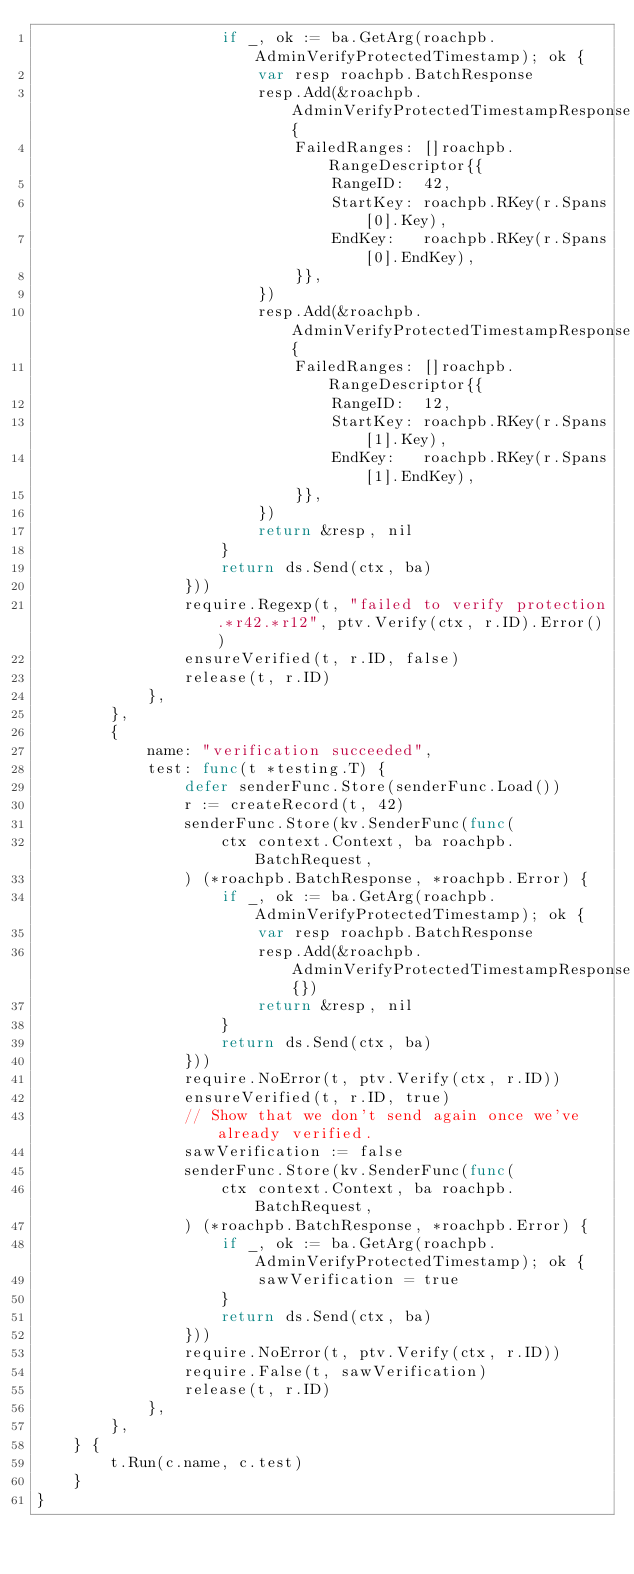<code> <loc_0><loc_0><loc_500><loc_500><_Go_>					if _, ok := ba.GetArg(roachpb.AdminVerifyProtectedTimestamp); ok {
						var resp roachpb.BatchResponse
						resp.Add(&roachpb.AdminVerifyProtectedTimestampResponse{
							FailedRanges: []roachpb.RangeDescriptor{{
								RangeID:  42,
								StartKey: roachpb.RKey(r.Spans[0].Key),
								EndKey:   roachpb.RKey(r.Spans[0].EndKey),
							}},
						})
						resp.Add(&roachpb.AdminVerifyProtectedTimestampResponse{
							FailedRanges: []roachpb.RangeDescriptor{{
								RangeID:  12,
								StartKey: roachpb.RKey(r.Spans[1].Key),
								EndKey:   roachpb.RKey(r.Spans[1].EndKey),
							}},
						})
						return &resp, nil
					}
					return ds.Send(ctx, ba)
				}))
				require.Regexp(t, "failed to verify protection.*r42.*r12", ptv.Verify(ctx, r.ID).Error())
				ensureVerified(t, r.ID, false)
				release(t, r.ID)
			},
		},
		{
			name: "verification succeeded",
			test: func(t *testing.T) {
				defer senderFunc.Store(senderFunc.Load())
				r := createRecord(t, 42)
				senderFunc.Store(kv.SenderFunc(func(
					ctx context.Context, ba roachpb.BatchRequest,
				) (*roachpb.BatchResponse, *roachpb.Error) {
					if _, ok := ba.GetArg(roachpb.AdminVerifyProtectedTimestamp); ok {
						var resp roachpb.BatchResponse
						resp.Add(&roachpb.AdminVerifyProtectedTimestampResponse{})
						return &resp, nil
					}
					return ds.Send(ctx, ba)
				}))
				require.NoError(t, ptv.Verify(ctx, r.ID))
				ensureVerified(t, r.ID, true)
				// Show that we don't send again once we've already verified.
				sawVerification := false
				senderFunc.Store(kv.SenderFunc(func(
					ctx context.Context, ba roachpb.BatchRequest,
				) (*roachpb.BatchResponse, *roachpb.Error) {
					if _, ok := ba.GetArg(roachpb.AdminVerifyProtectedTimestamp); ok {
						sawVerification = true
					}
					return ds.Send(ctx, ba)
				}))
				require.NoError(t, ptv.Verify(ctx, r.ID))
				require.False(t, sawVerification)
				release(t, r.ID)
			},
		},
	} {
		t.Run(c.name, c.test)
	}
}
</code> 